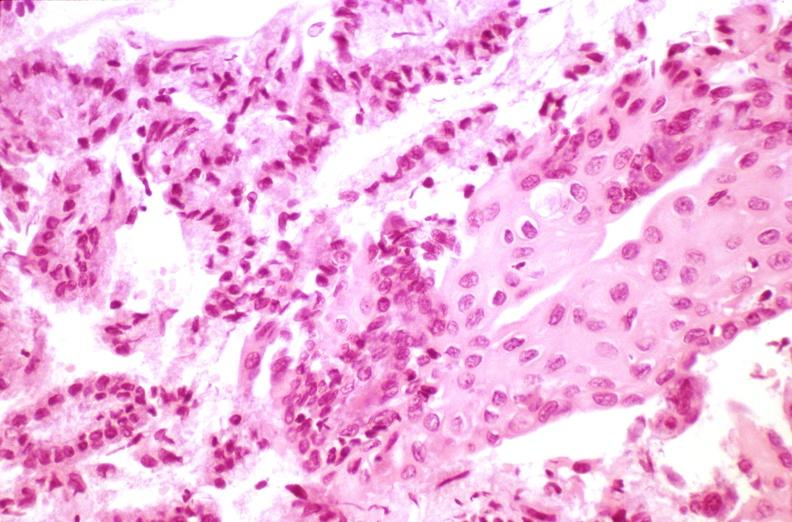does outside adrenal capsule section show cervix, squamous metaplasia?
Answer the question using a single word or phrase. No 